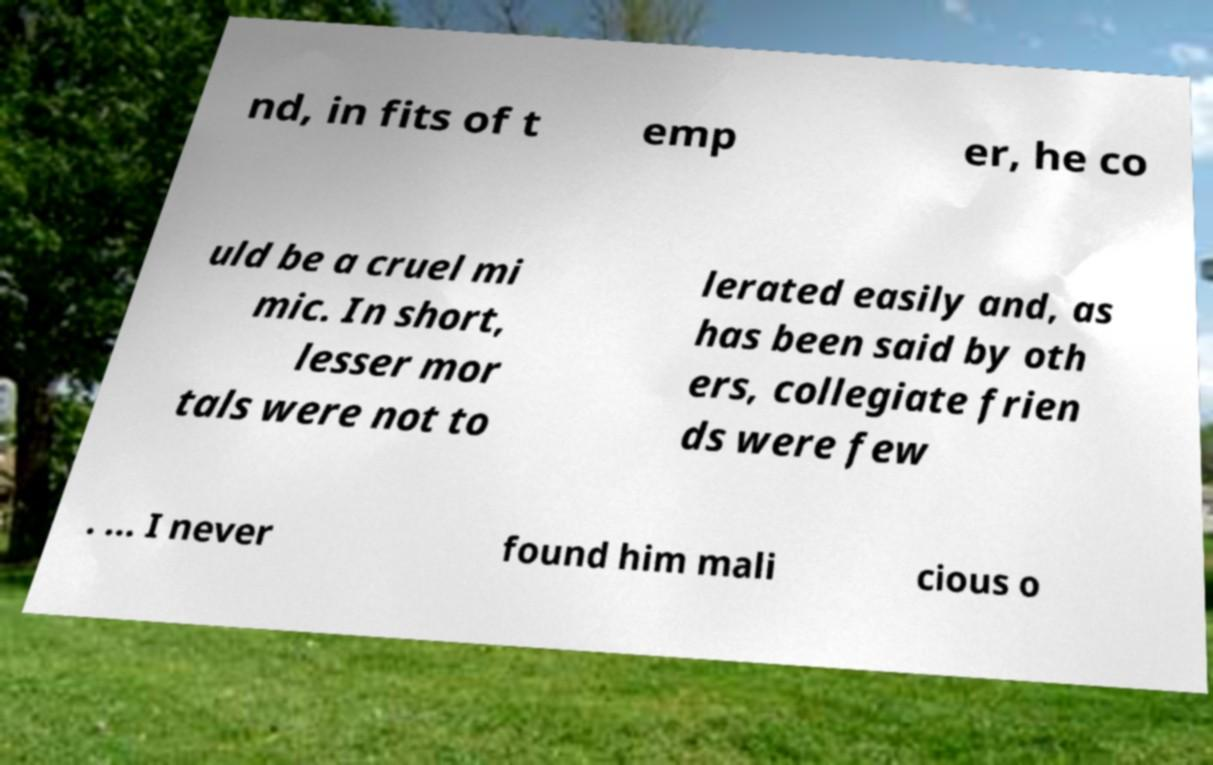Could you extract and type out the text from this image? nd, in fits of t emp er, he co uld be a cruel mi mic. In short, lesser mor tals were not to lerated easily and, as has been said by oth ers, collegiate frien ds were few . ... I never found him mali cious o 